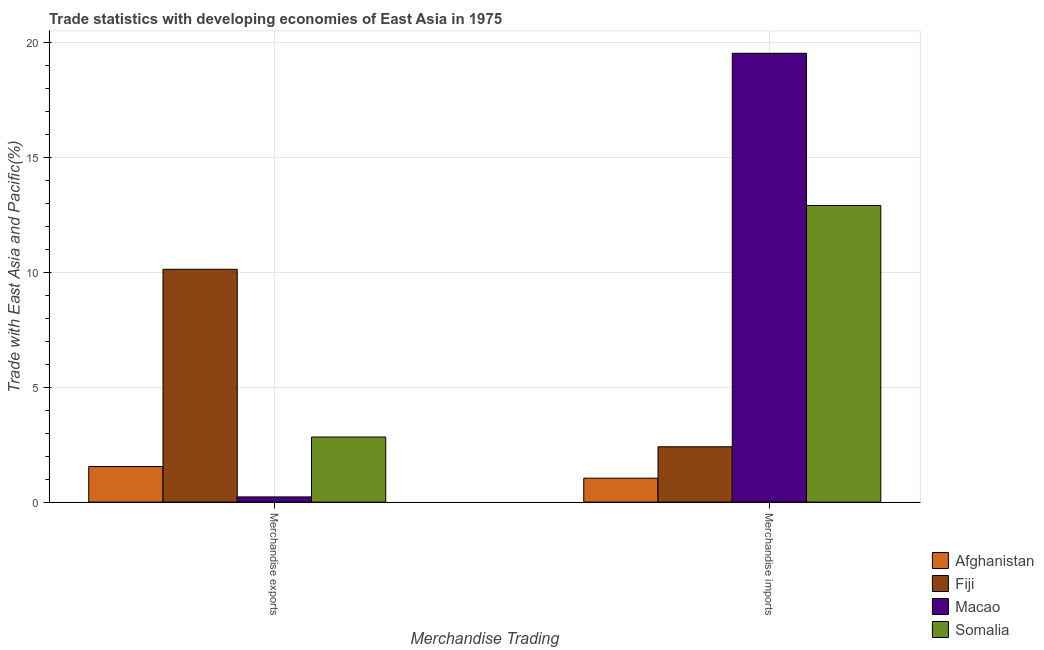How many bars are there on the 2nd tick from the left?
Provide a succinct answer. 4. How many bars are there on the 2nd tick from the right?
Your answer should be very brief. 4. What is the label of the 1st group of bars from the left?
Provide a short and direct response. Merchandise exports. What is the merchandise imports in Macao?
Your answer should be compact. 19.55. Across all countries, what is the maximum merchandise exports?
Provide a succinct answer. 10.14. Across all countries, what is the minimum merchandise imports?
Your answer should be compact. 1.04. In which country was the merchandise imports maximum?
Your response must be concise. Macao. In which country was the merchandise exports minimum?
Keep it short and to the point. Macao. What is the total merchandise imports in the graph?
Your response must be concise. 35.92. What is the difference between the merchandise imports in Fiji and that in Afghanistan?
Your response must be concise. 1.37. What is the difference between the merchandise imports in Somalia and the merchandise exports in Macao?
Your response must be concise. 12.69. What is the average merchandise imports per country?
Provide a short and direct response. 8.98. What is the difference between the merchandise exports and merchandise imports in Somalia?
Ensure brevity in your answer.  -10.08. What is the ratio of the merchandise imports in Macao to that in Somalia?
Your answer should be compact. 1.51. Is the merchandise exports in Afghanistan less than that in Somalia?
Your answer should be compact. Yes. In how many countries, is the merchandise exports greater than the average merchandise exports taken over all countries?
Give a very brief answer. 1. What does the 1st bar from the left in Merchandise imports represents?
Your response must be concise. Afghanistan. What does the 4th bar from the right in Merchandise exports represents?
Ensure brevity in your answer.  Afghanistan. How many bars are there?
Offer a very short reply. 8. Does the graph contain any zero values?
Give a very brief answer. No. How many legend labels are there?
Your answer should be compact. 4. How are the legend labels stacked?
Your answer should be very brief. Vertical. What is the title of the graph?
Provide a succinct answer. Trade statistics with developing economies of East Asia in 1975. Does "Andorra" appear as one of the legend labels in the graph?
Ensure brevity in your answer.  No. What is the label or title of the X-axis?
Give a very brief answer. Merchandise Trading. What is the label or title of the Y-axis?
Offer a very short reply. Trade with East Asia and Pacific(%). What is the Trade with East Asia and Pacific(%) of Afghanistan in Merchandise exports?
Your answer should be very brief. 1.55. What is the Trade with East Asia and Pacific(%) in Fiji in Merchandise exports?
Keep it short and to the point. 10.14. What is the Trade with East Asia and Pacific(%) in Macao in Merchandise exports?
Your response must be concise. 0.23. What is the Trade with East Asia and Pacific(%) of Somalia in Merchandise exports?
Your answer should be compact. 2.83. What is the Trade with East Asia and Pacific(%) of Afghanistan in Merchandise imports?
Provide a succinct answer. 1.04. What is the Trade with East Asia and Pacific(%) of Fiji in Merchandise imports?
Your response must be concise. 2.41. What is the Trade with East Asia and Pacific(%) of Macao in Merchandise imports?
Your response must be concise. 19.55. What is the Trade with East Asia and Pacific(%) of Somalia in Merchandise imports?
Make the answer very short. 12.92. Across all Merchandise Trading, what is the maximum Trade with East Asia and Pacific(%) in Afghanistan?
Provide a succinct answer. 1.55. Across all Merchandise Trading, what is the maximum Trade with East Asia and Pacific(%) in Fiji?
Make the answer very short. 10.14. Across all Merchandise Trading, what is the maximum Trade with East Asia and Pacific(%) in Macao?
Your response must be concise. 19.55. Across all Merchandise Trading, what is the maximum Trade with East Asia and Pacific(%) in Somalia?
Keep it short and to the point. 12.92. Across all Merchandise Trading, what is the minimum Trade with East Asia and Pacific(%) of Afghanistan?
Offer a very short reply. 1.04. Across all Merchandise Trading, what is the minimum Trade with East Asia and Pacific(%) in Fiji?
Offer a terse response. 2.41. Across all Merchandise Trading, what is the minimum Trade with East Asia and Pacific(%) of Macao?
Ensure brevity in your answer.  0.23. Across all Merchandise Trading, what is the minimum Trade with East Asia and Pacific(%) in Somalia?
Make the answer very short. 2.83. What is the total Trade with East Asia and Pacific(%) of Afghanistan in the graph?
Make the answer very short. 2.59. What is the total Trade with East Asia and Pacific(%) of Fiji in the graph?
Give a very brief answer. 12.55. What is the total Trade with East Asia and Pacific(%) in Macao in the graph?
Your answer should be very brief. 19.77. What is the total Trade with East Asia and Pacific(%) in Somalia in the graph?
Your response must be concise. 15.75. What is the difference between the Trade with East Asia and Pacific(%) in Afghanistan in Merchandise exports and that in Merchandise imports?
Keep it short and to the point. 0.51. What is the difference between the Trade with East Asia and Pacific(%) in Fiji in Merchandise exports and that in Merchandise imports?
Your response must be concise. 7.73. What is the difference between the Trade with East Asia and Pacific(%) of Macao in Merchandise exports and that in Merchandise imports?
Provide a short and direct response. -19.32. What is the difference between the Trade with East Asia and Pacific(%) in Somalia in Merchandise exports and that in Merchandise imports?
Keep it short and to the point. -10.08. What is the difference between the Trade with East Asia and Pacific(%) in Afghanistan in Merchandise exports and the Trade with East Asia and Pacific(%) in Fiji in Merchandise imports?
Keep it short and to the point. -0.86. What is the difference between the Trade with East Asia and Pacific(%) of Afghanistan in Merchandise exports and the Trade with East Asia and Pacific(%) of Macao in Merchandise imports?
Offer a terse response. -18. What is the difference between the Trade with East Asia and Pacific(%) of Afghanistan in Merchandise exports and the Trade with East Asia and Pacific(%) of Somalia in Merchandise imports?
Give a very brief answer. -11.37. What is the difference between the Trade with East Asia and Pacific(%) of Fiji in Merchandise exports and the Trade with East Asia and Pacific(%) of Macao in Merchandise imports?
Your answer should be compact. -9.41. What is the difference between the Trade with East Asia and Pacific(%) of Fiji in Merchandise exports and the Trade with East Asia and Pacific(%) of Somalia in Merchandise imports?
Offer a terse response. -2.78. What is the difference between the Trade with East Asia and Pacific(%) of Macao in Merchandise exports and the Trade with East Asia and Pacific(%) of Somalia in Merchandise imports?
Provide a short and direct response. -12.69. What is the average Trade with East Asia and Pacific(%) in Afghanistan per Merchandise Trading?
Provide a succinct answer. 1.3. What is the average Trade with East Asia and Pacific(%) of Fiji per Merchandise Trading?
Offer a very short reply. 6.27. What is the average Trade with East Asia and Pacific(%) of Macao per Merchandise Trading?
Keep it short and to the point. 9.89. What is the average Trade with East Asia and Pacific(%) in Somalia per Merchandise Trading?
Provide a short and direct response. 7.88. What is the difference between the Trade with East Asia and Pacific(%) of Afghanistan and Trade with East Asia and Pacific(%) of Fiji in Merchandise exports?
Make the answer very short. -8.59. What is the difference between the Trade with East Asia and Pacific(%) in Afghanistan and Trade with East Asia and Pacific(%) in Macao in Merchandise exports?
Your answer should be very brief. 1.32. What is the difference between the Trade with East Asia and Pacific(%) of Afghanistan and Trade with East Asia and Pacific(%) of Somalia in Merchandise exports?
Provide a short and direct response. -1.28. What is the difference between the Trade with East Asia and Pacific(%) in Fiji and Trade with East Asia and Pacific(%) in Macao in Merchandise exports?
Make the answer very short. 9.91. What is the difference between the Trade with East Asia and Pacific(%) in Fiji and Trade with East Asia and Pacific(%) in Somalia in Merchandise exports?
Provide a succinct answer. 7.3. What is the difference between the Trade with East Asia and Pacific(%) of Macao and Trade with East Asia and Pacific(%) of Somalia in Merchandise exports?
Provide a short and direct response. -2.61. What is the difference between the Trade with East Asia and Pacific(%) of Afghanistan and Trade with East Asia and Pacific(%) of Fiji in Merchandise imports?
Your answer should be compact. -1.37. What is the difference between the Trade with East Asia and Pacific(%) in Afghanistan and Trade with East Asia and Pacific(%) in Macao in Merchandise imports?
Give a very brief answer. -18.5. What is the difference between the Trade with East Asia and Pacific(%) in Afghanistan and Trade with East Asia and Pacific(%) in Somalia in Merchandise imports?
Make the answer very short. -11.87. What is the difference between the Trade with East Asia and Pacific(%) of Fiji and Trade with East Asia and Pacific(%) of Macao in Merchandise imports?
Keep it short and to the point. -17.14. What is the difference between the Trade with East Asia and Pacific(%) in Fiji and Trade with East Asia and Pacific(%) in Somalia in Merchandise imports?
Make the answer very short. -10.51. What is the difference between the Trade with East Asia and Pacific(%) in Macao and Trade with East Asia and Pacific(%) in Somalia in Merchandise imports?
Keep it short and to the point. 6.63. What is the ratio of the Trade with East Asia and Pacific(%) in Afghanistan in Merchandise exports to that in Merchandise imports?
Your response must be concise. 1.49. What is the ratio of the Trade with East Asia and Pacific(%) of Fiji in Merchandise exports to that in Merchandise imports?
Offer a very short reply. 4.21. What is the ratio of the Trade with East Asia and Pacific(%) of Macao in Merchandise exports to that in Merchandise imports?
Your answer should be very brief. 0.01. What is the ratio of the Trade with East Asia and Pacific(%) of Somalia in Merchandise exports to that in Merchandise imports?
Your answer should be compact. 0.22. What is the difference between the highest and the second highest Trade with East Asia and Pacific(%) in Afghanistan?
Make the answer very short. 0.51. What is the difference between the highest and the second highest Trade with East Asia and Pacific(%) of Fiji?
Offer a very short reply. 7.73. What is the difference between the highest and the second highest Trade with East Asia and Pacific(%) in Macao?
Your answer should be very brief. 19.32. What is the difference between the highest and the second highest Trade with East Asia and Pacific(%) in Somalia?
Offer a very short reply. 10.08. What is the difference between the highest and the lowest Trade with East Asia and Pacific(%) of Afghanistan?
Your answer should be very brief. 0.51. What is the difference between the highest and the lowest Trade with East Asia and Pacific(%) in Fiji?
Keep it short and to the point. 7.73. What is the difference between the highest and the lowest Trade with East Asia and Pacific(%) in Macao?
Keep it short and to the point. 19.32. What is the difference between the highest and the lowest Trade with East Asia and Pacific(%) of Somalia?
Your answer should be compact. 10.08. 